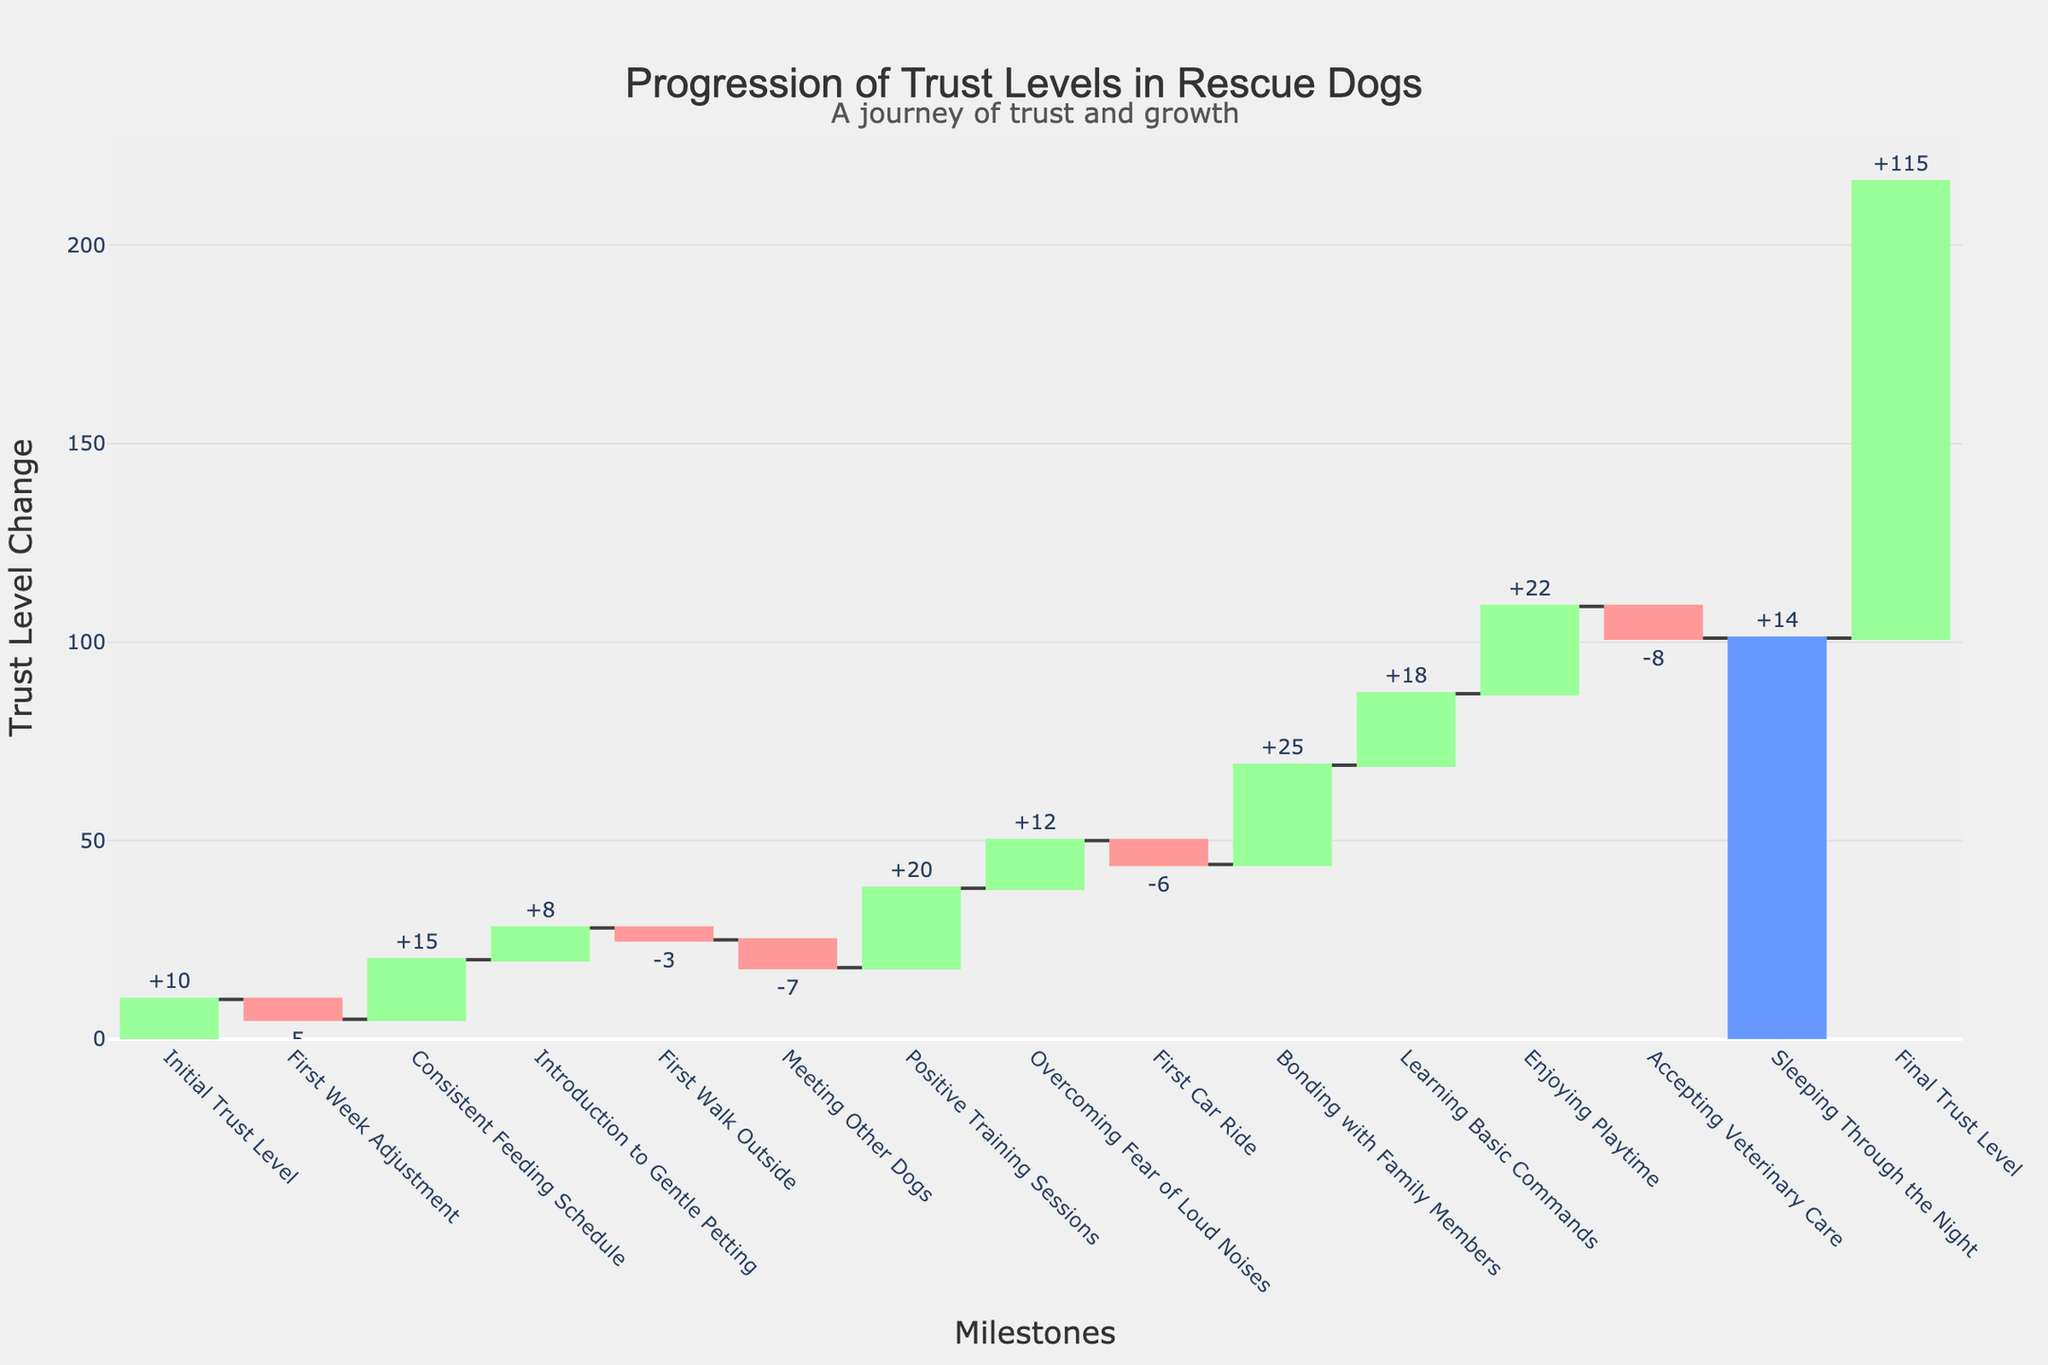What's the title of the figure? The title of the figure is prominently displayed at the top center of the chart. It reads "Progression of Trust Levels in Rescue Dogs".
Answer: Progression of Trust Levels in Rescue Dogs How many milestone categories are there? By counting the labels on the x-axis of the waterfall chart, we see there are 14 milestone categories.
Answer: 14 Which milestone had the largest positive impact on trust level? Looking at the heights of the bars, "Bonding with Family Members" has the highest positive value at 25.
Answer: Bonding with Family Members What was the overall change in trust level from the initial to the final state? The initial trust level was 10, and the final trust level is indicated as 115. The overall change is the difference between these two values: 115 - 10.
Answer: +105 What does the color green represent in the figure? Green bars indicate an increase in trust levels at specific milestones.
Answer: Increase in trust levels Which milestones decreased the trust level? The red bars represent decreases in trust levels. The milestones with red bars are "First Week Adjustment", "First Walk Outside", "Meeting Other Dogs", "First Car Ride", and "Accepting Veterinary Care".
Answer: First Week Adjustment, First Walk Outside, Meeting Other Dogs, First Car Ride, Accepting Veterinary Care What is the cumulative trust level after consistent feeding schedule? The cumulative trust level after "Consistent Feeding Schedule" can be determined by summing the initial trust level and the values up to this milestone: 10 (Initial Trust Level) - 5 (First Week Adjustment) + 15 (Consistent Feeding Schedule) = 20.
Answer: 20 Which milestone corresponds to the smallest increase in trust level? Among the green bars, "Introduction to Gentle Petting" has the smallest increase at +8.
Answer: Introduction to Gentle Petting How does "Learning Basic Commands" impact the trust level compared to "Enjoying Playtime"? "Learning Basic Commands" increases trust level by 18, whereas "Enjoying Playtime" increases it by 22. Enjoying Playtime has a greater positive impact by 4.
Answer: Enjoying Playtime has a greater positive impact by 4 What is the total trust level change caused by negative milestones? The negative milestones are identified by red bars: -5, -3, -7, -6, and -8. Summing these values: -5 - 3 - 7 - 6 - 8 = -29.
Answer: -29 